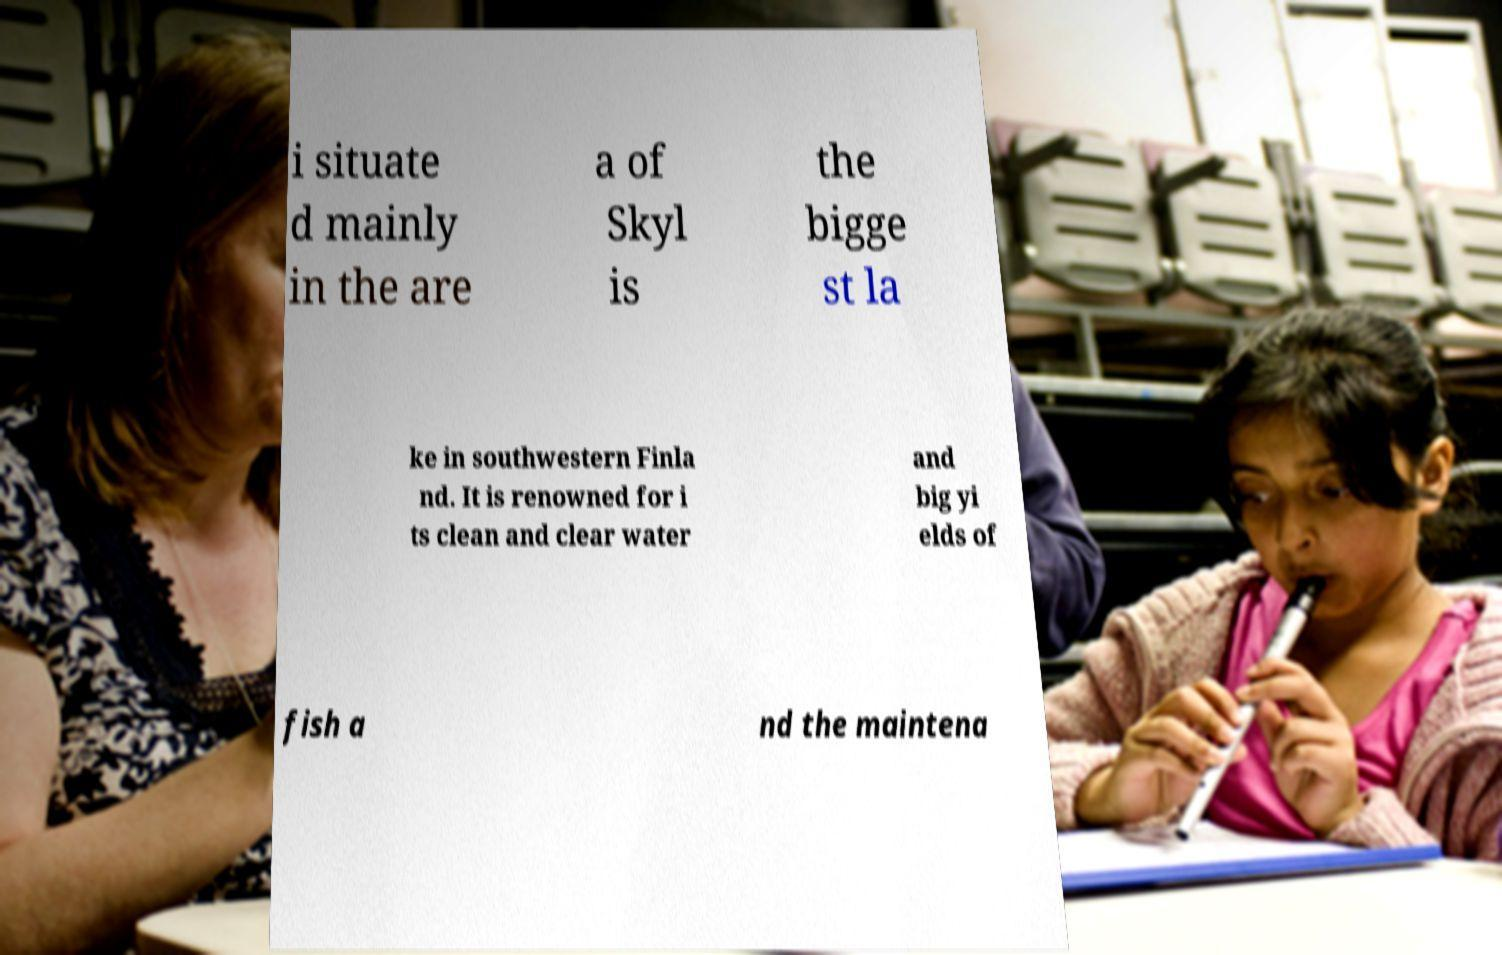Can you read and provide the text displayed in the image?This photo seems to have some interesting text. Can you extract and type it out for me? i situate d mainly in the are a of Skyl is the bigge st la ke in southwestern Finla nd. It is renowned for i ts clean and clear water and big yi elds of fish a nd the maintena 